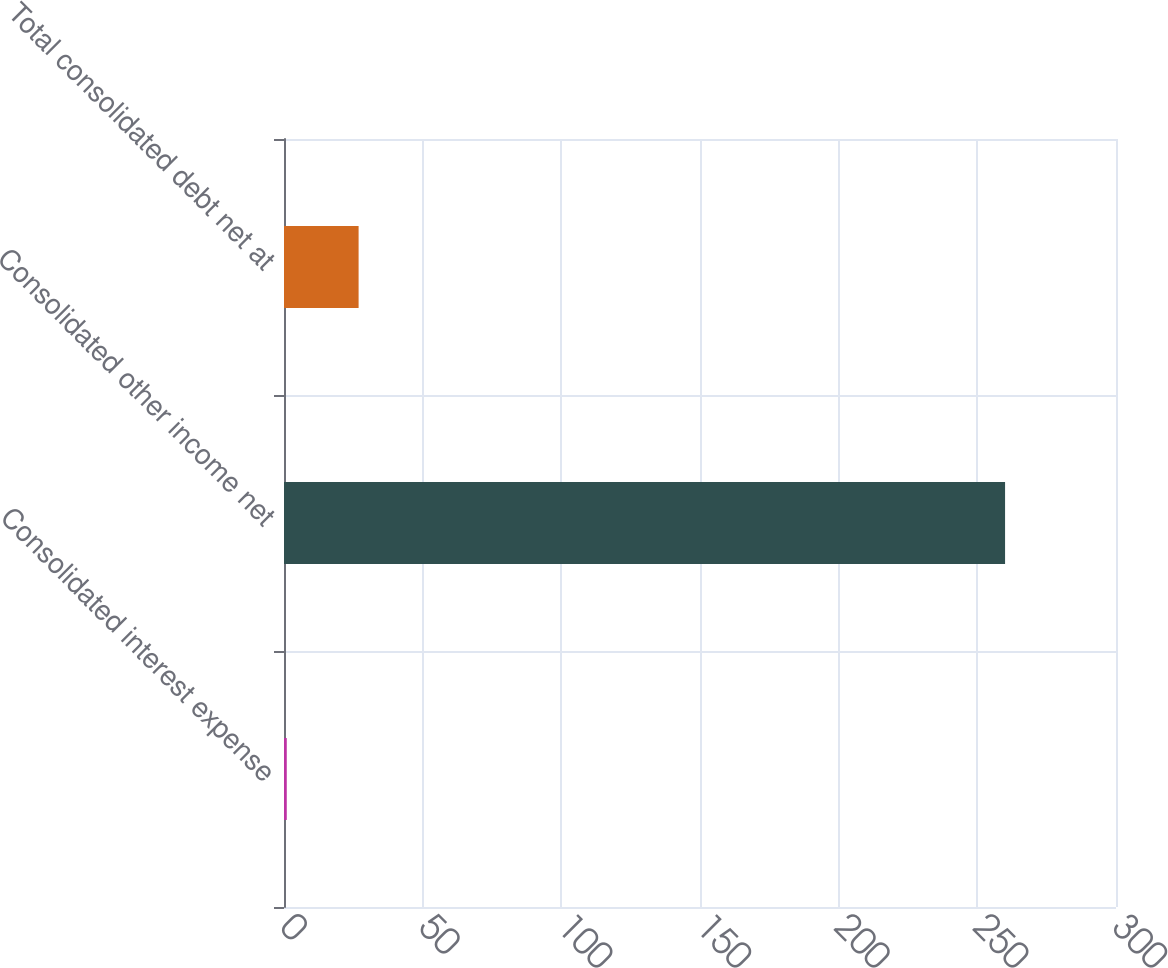Convert chart. <chart><loc_0><loc_0><loc_500><loc_500><bar_chart><fcel>Consolidated interest expense<fcel>Consolidated other income net<fcel>Total consolidated debt net at<nl><fcel>1<fcel>260<fcel>26.9<nl></chart> 